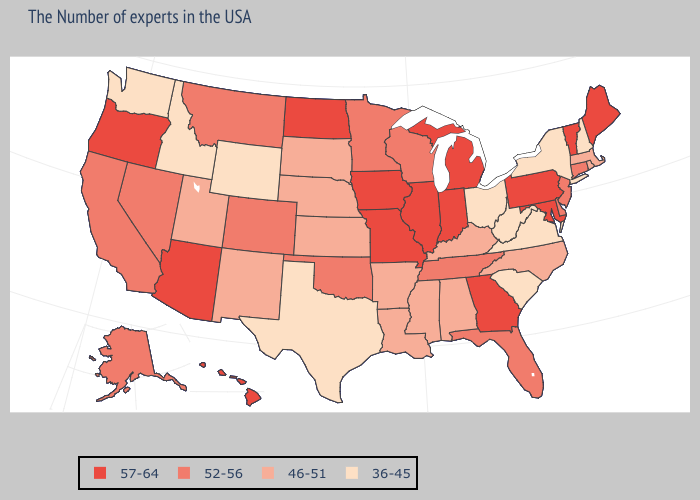Among the states that border Arkansas , does Texas have the lowest value?
Keep it brief. Yes. What is the lowest value in states that border Massachusetts?
Write a very short answer. 36-45. Which states hav the highest value in the MidWest?
Concise answer only. Michigan, Indiana, Illinois, Missouri, Iowa, North Dakota. Name the states that have a value in the range 36-45?
Give a very brief answer. New Hampshire, New York, Virginia, South Carolina, West Virginia, Ohio, Texas, Wyoming, Idaho, Washington. Name the states that have a value in the range 52-56?
Be succinct. Connecticut, New Jersey, Delaware, Florida, Tennessee, Wisconsin, Minnesota, Oklahoma, Colorado, Montana, Nevada, California, Alaska. What is the value of Wyoming?
Give a very brief answer. 36-45. Name the states that have a value in the range 46-51?
Give a very brief answer. Massachusetts, Rhode Island, North Carolina, Kentucky, Alabama, Mississippi, Louisiana, Arkansas, Kansas, Nebraska, South Dakota, New Mexico, Utah. What is the value of Minnesota?
Give a very brief answer. 52-56. What is the value of Arkansas?
Quick response, please. 46-51. Name the states that have a value in the range 46-51?
Keep it brief. Massachusetts, Rhode Island, North Carolina, Kentucky, Alabama, Mississippi, Louisiana, Arkansas, Kansas, Nebraska, South Dakota, New Mexico, Utah. Does Arkansas have a lower value than North Dakota?
Short answer required. Yes. Among the states that border Texas , which have the highest value?
Be succinct. Oklahoma. What is the value of Maryland?
Concise answer only. 57-64. Name the states that have a value in the range 52-56?
Be succinct. Connecticut, New Jersey, Delaware, Florida, Tennessee, Wisconsin, Minnesota, Oklahoma, Colorado, Montana, Nevada, California, Alaska. What is the value of Missouri?
Keep it brief. 57-64. 